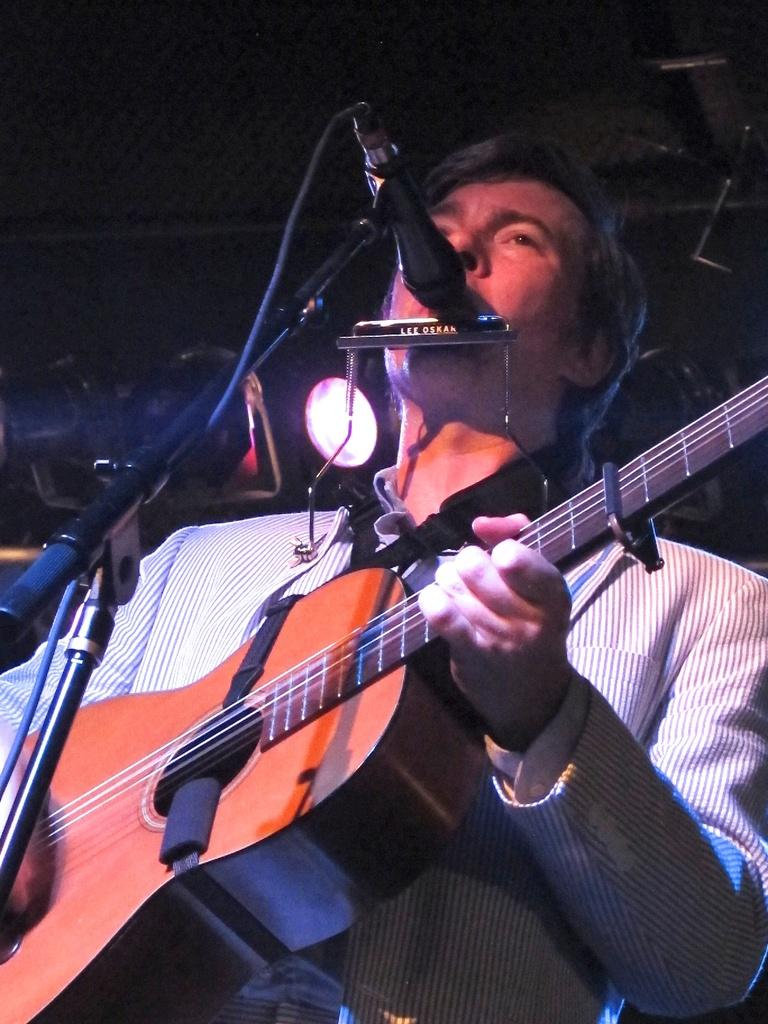Who is the person in the image? There is a man in the image. What is the man doing in the image? The man is playing a guitar. What object is present in the image that is commonly used for amplifying sound? There is a microphone in the image. What type of dinosaur can be seen in the background of the image? There are no dinosaurs present in the image; it features a man playing a guitar and a microphone. What color is the sweater the man is wearing in the image? The provided facts do not mention the man wearing a sweater, so we cannot determine the color of a sweater in the image. 